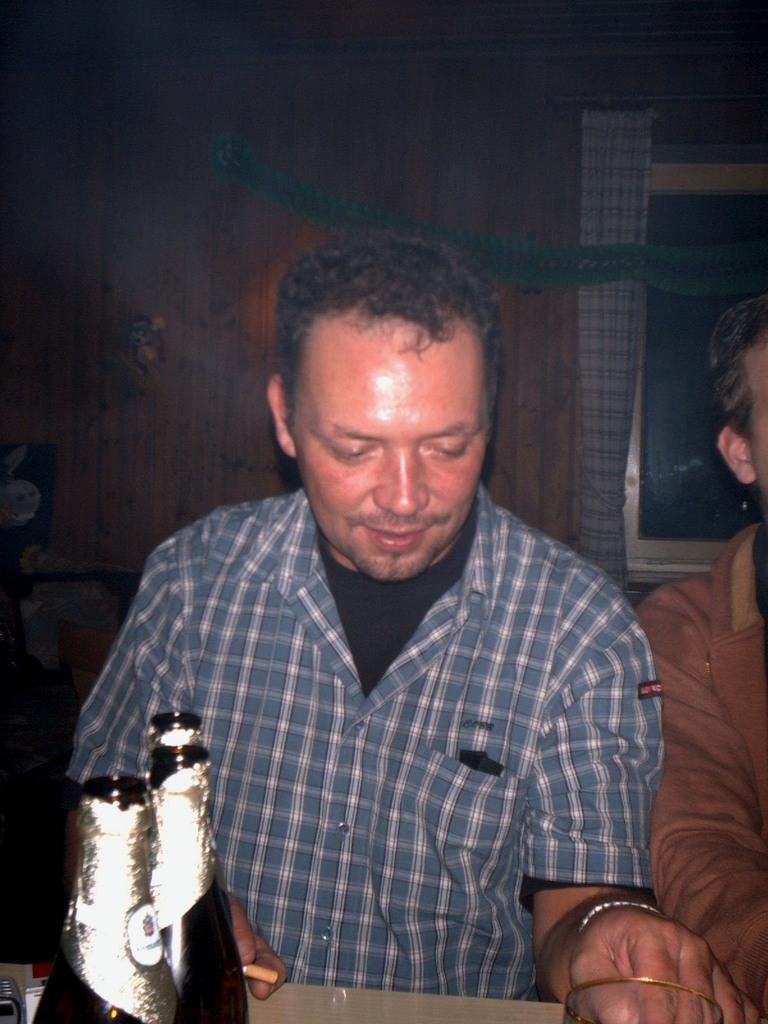Who is present in the image? There is a man in the image. What is located on the table in the image? There are bottles and a glass on the table in the image. What can be seen in the background of the image? There is a wall and a window in the background of the image. Is there any window treatment present in the image? Yes, there is a curtain associated with the window. What is the title of the feast being held in the image? There is no feast present in the image, so there is no title to be determined. 